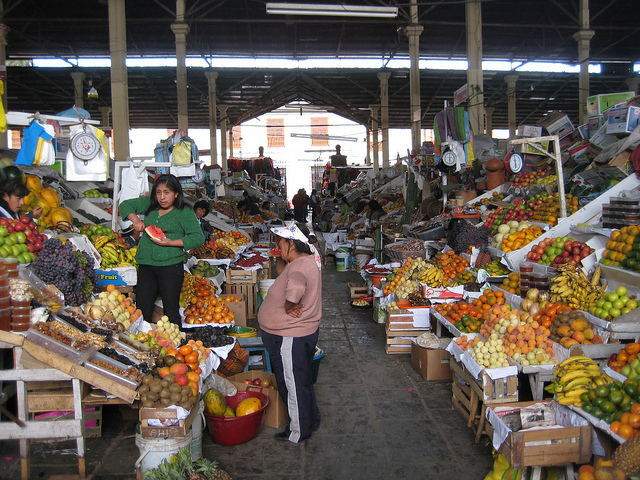How many people are there? There are at least two people visible in the image, standing among stalls that are brimming with various fruits and other goods, suggesting a lively market scene. 